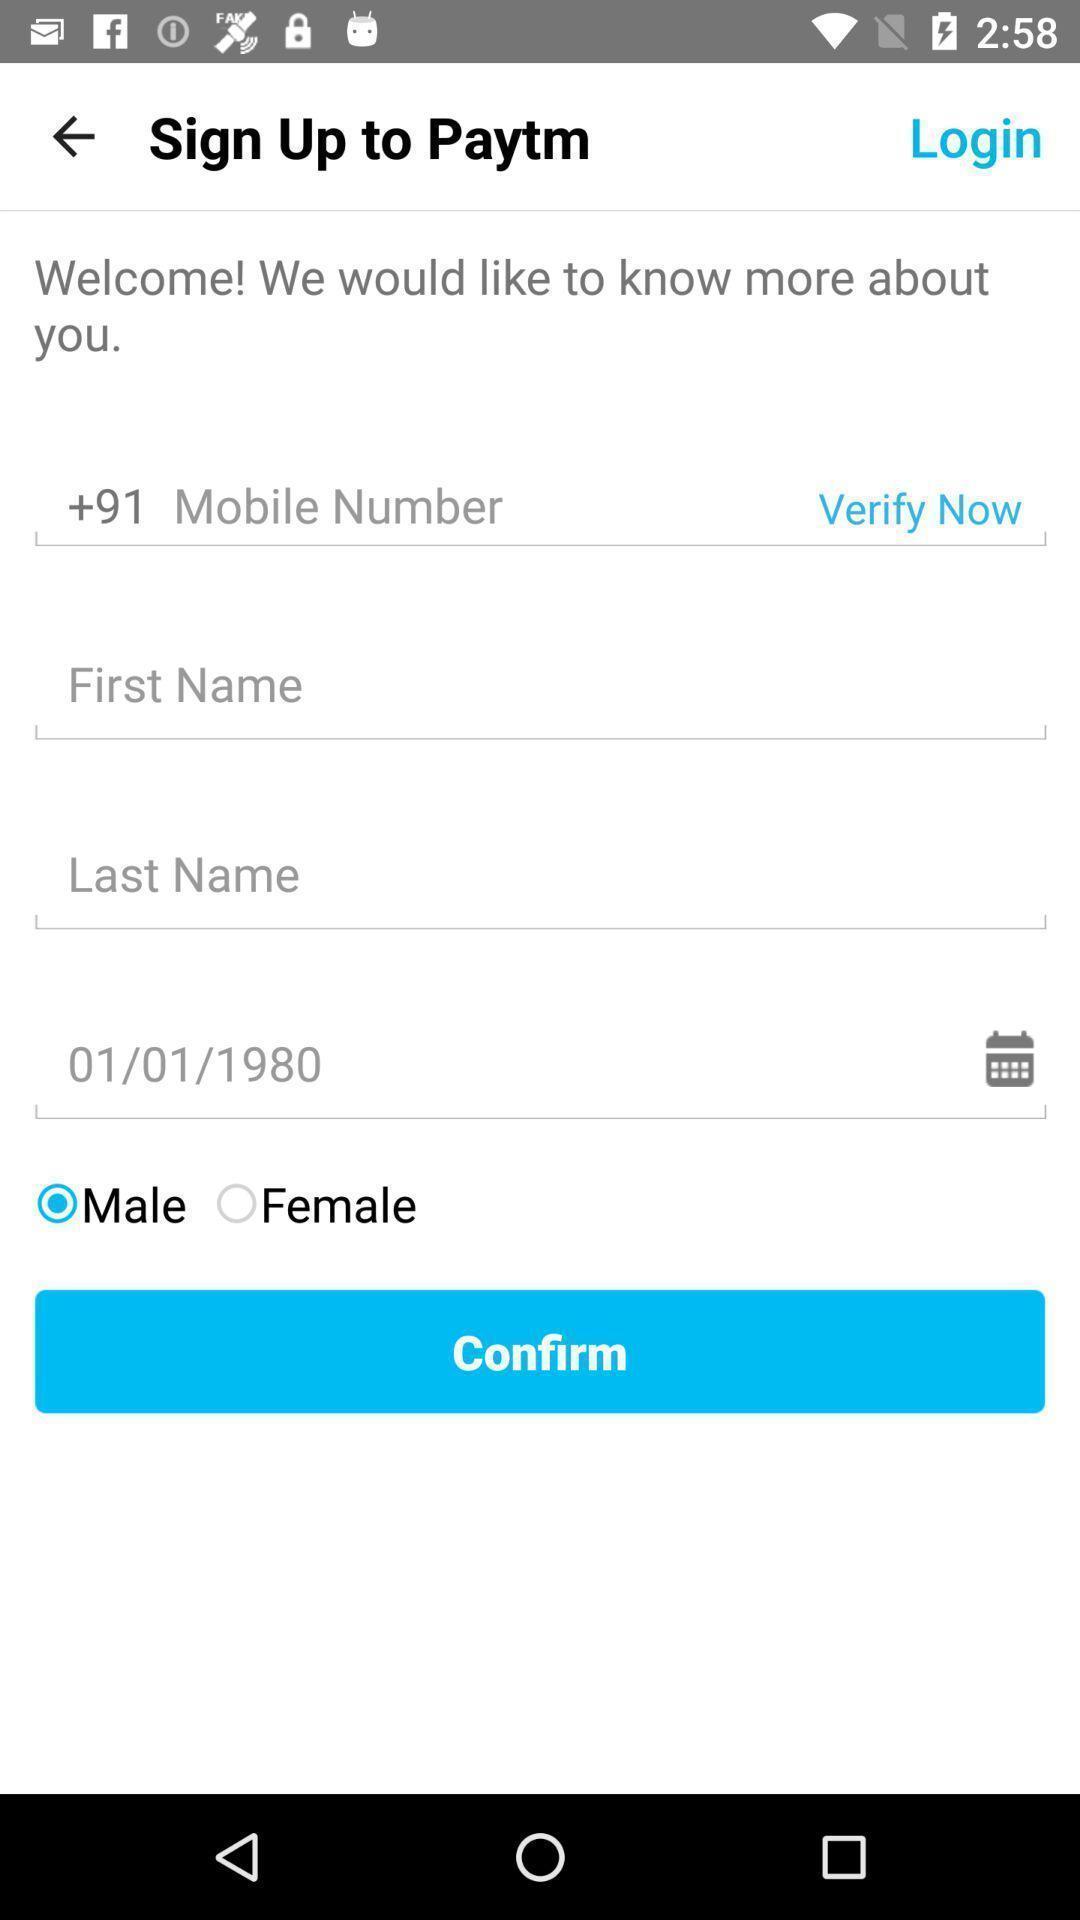Provide a textual representation of this image. Sign up page. 